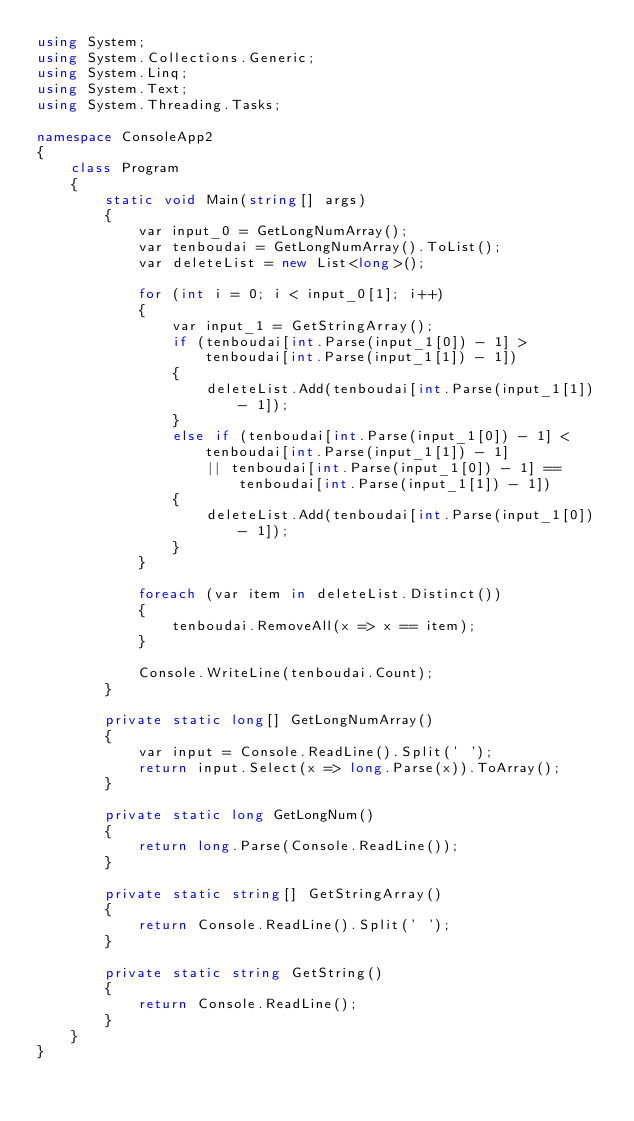<code> <loc_0><loc_0><loc_500><loc_500><_C#_>using System;
using System.Collections.Generic;
using System.Linq;
using System.Text;
using System.Threading.Tasks;

namespace ConsoleApp2
{
    class Program
    {
        static void Main(string[] args)
        {
            var input_0 = GetLongNumArray();
            var tenboudai = GetLongNumArray().ToList();
            var deleteList = new List<long>();

            for (int i = 0; i < input_0[1]; i++)
            {
                var input_1 = GetStringArray();
                if (tenboudai[int.Parse(input_1[0]) - 1] > tenboudai[int.Parse(input_1[1]) - 1])
                {
                    deleteList.Add(tenboudai[int.Parse(input_1[1]) - 1]);
                }
                else if (tenboudai[int.Parse(input_1[0]) - 1] < tenboudai[int.Parse(input_1[1]) - 1]
                    || tenboudai[int.Parse(input_1[0]) - 1] == tenboudai[int.Parse(input_1[1]) - 1])
                {
                    deleteList.Add(tenboudai[int.Parse(input_1[0]) - 1]);
                }
            }

            foreach (var item in deleteList.Distinct())
            {
                tenboudai.RemoveAll(x => x == item);
            }

            Console.WriteLine(tenboudai.Count);
        }

        private static long[] GetLongNumArray()
        {
            var input = Console.ReadLine().Split(' ');
            return input.Select(x => long.Parse(x)).ToArray();
        }

        private static long GetLongNum()
        {
            return long.Parse(Console.ReadLine());
        }

        private static string[] GetStringArray()
        {
            return Console.ReadLine().Split(' ');
        }

        private static string GetString()
        {
            return Console.ReadLine();
        }
    }
}
</code> 